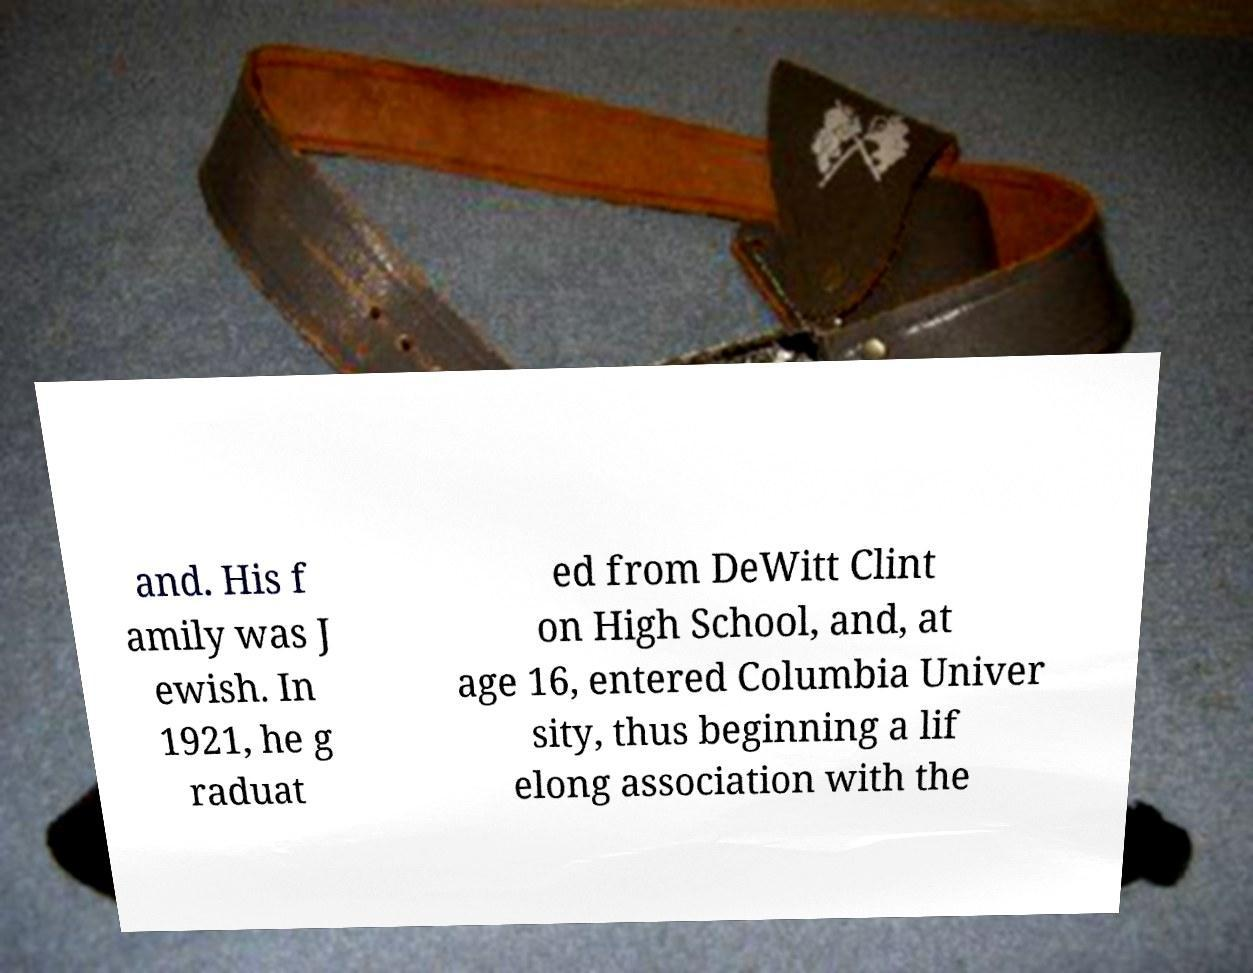What messages or text are displayed in this image? I need them in a readable, typed format. and. His f amily was J ewish. In 1921, he g raduat ed from DeWitt Clint on High School, and, at age 16, entered Columbia Univer sity, thus beginning a lif elong association with the 